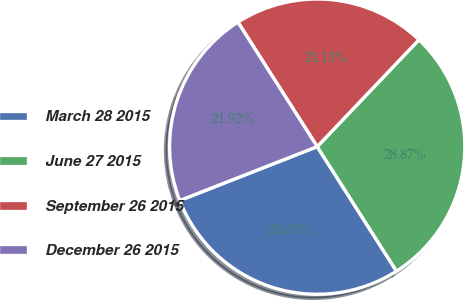Convert chart. <chart><loc_0><loc_0><loc_500><loc_500><pie_chart><fcel>March 28 2015<fcel>June 27 2015<fcel>September 26 2015<fcel>December 26 2015<nl><fcel>28.08%<fcel>28.87%<fcel>21.13%<fcel>21.92%<nl></chart> 